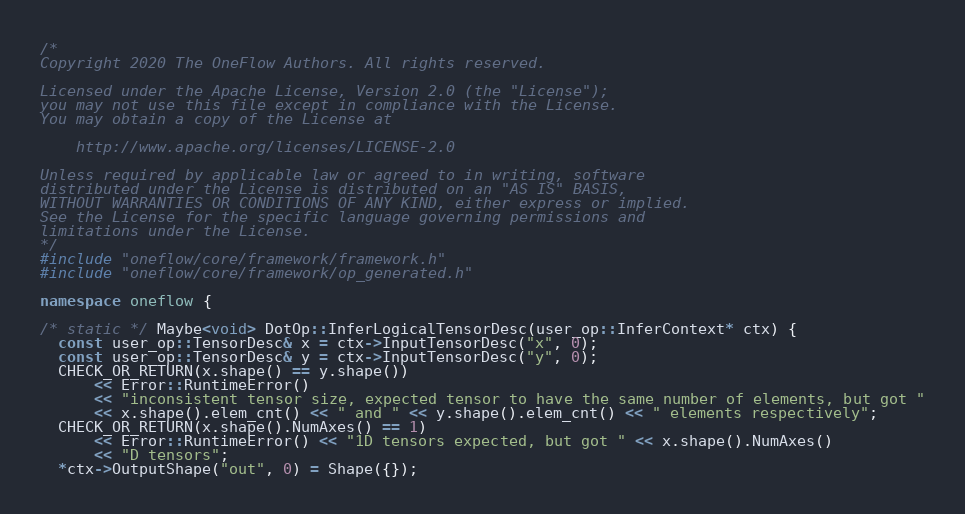<code> <loc_0><loc_0><loc_500><loc_500><_C++_>/*
Copyright 2020 The OneFlow Authors. All rights reserved.

Licensed under the Apache License, Version 2.0 (the "License");
you may not use this file except in compliance with the License.
You may obtain a copy of the License at

    http://www.apache.org/licenses/LICENSE-2.0

Unless required by applicable law or agreed to in writing, software
distributed under the License is distributed on an "AS IS" BASIS,
WITHOUT WARRANTIES OR CONDITIONS OF ANY KIND, either express or implied.
See the License for the specific language governing permissions and
limitations under the License.
*/
#include "oneflow/core/framework/framework.h"
#include "oneflow/core/framework/op_generated.h"

namespace oneflow {

/* static */ Maybe<void> DotOp::InferLogicalTensorDesc(user_op::InferContext* ctx) {
  const user_op::TensorDesc& x = ctx->InputTensorDesc("x", 0);
  const user_op::TensorDesc& y = ctx->InputTensorDesc("y", 0);
  CHECK_OR_RETURN(x.shape() == y.shape())
      << Error::RuntimeError()
      << "inconsistent tensor size, expected tensor to have the same number of elements, but got "
      << x.shape().elem_cnt() << " and " << y.shape().elem_cnt() << " elements respectively";
  CHECK_OR_RETURN(x.shape().NumAxes() == 1)
      << Error::RuntimeError() << "1D tensors expected, but got " << x.shape().NumAxes()
      << "D tensors";
  *ctx->OutputShape("out", 0) = Shape({});</code> 